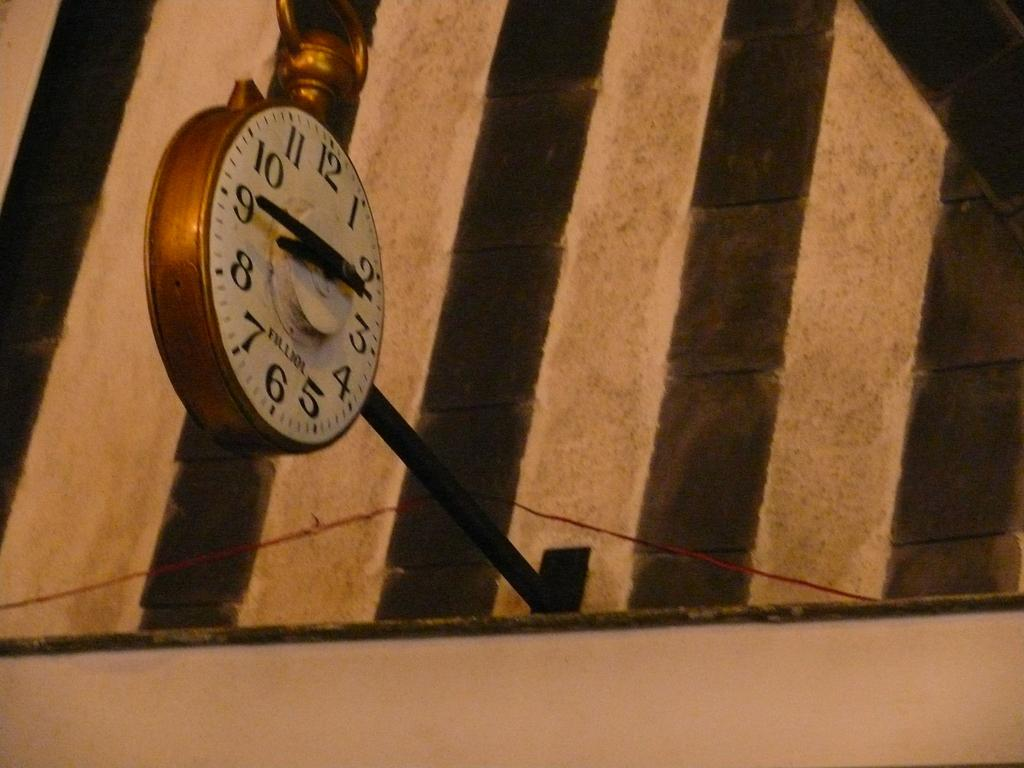<image>
Relay a brief, clear account of the picture shown. A clock with the name Filliol on it 